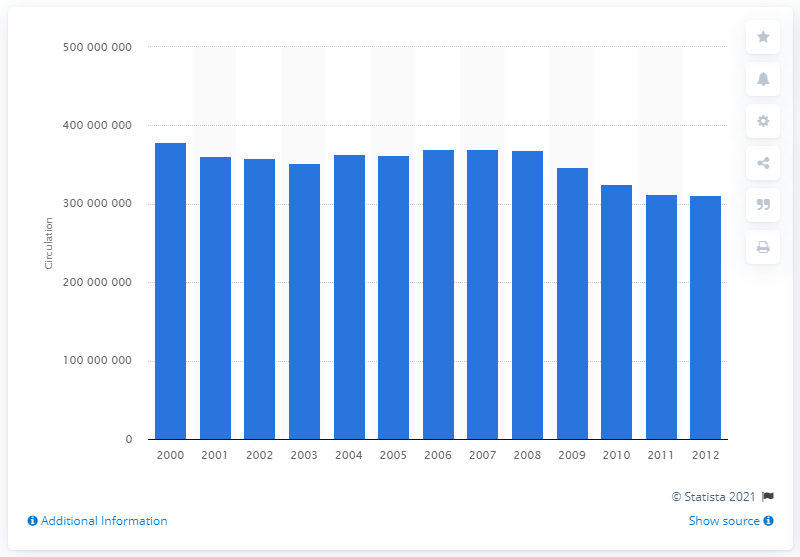Mention a couple of crucial points in this snapshot. During the period of 2000 to 2012, the combined circulation of magazines was approximately 352601091 copies. 